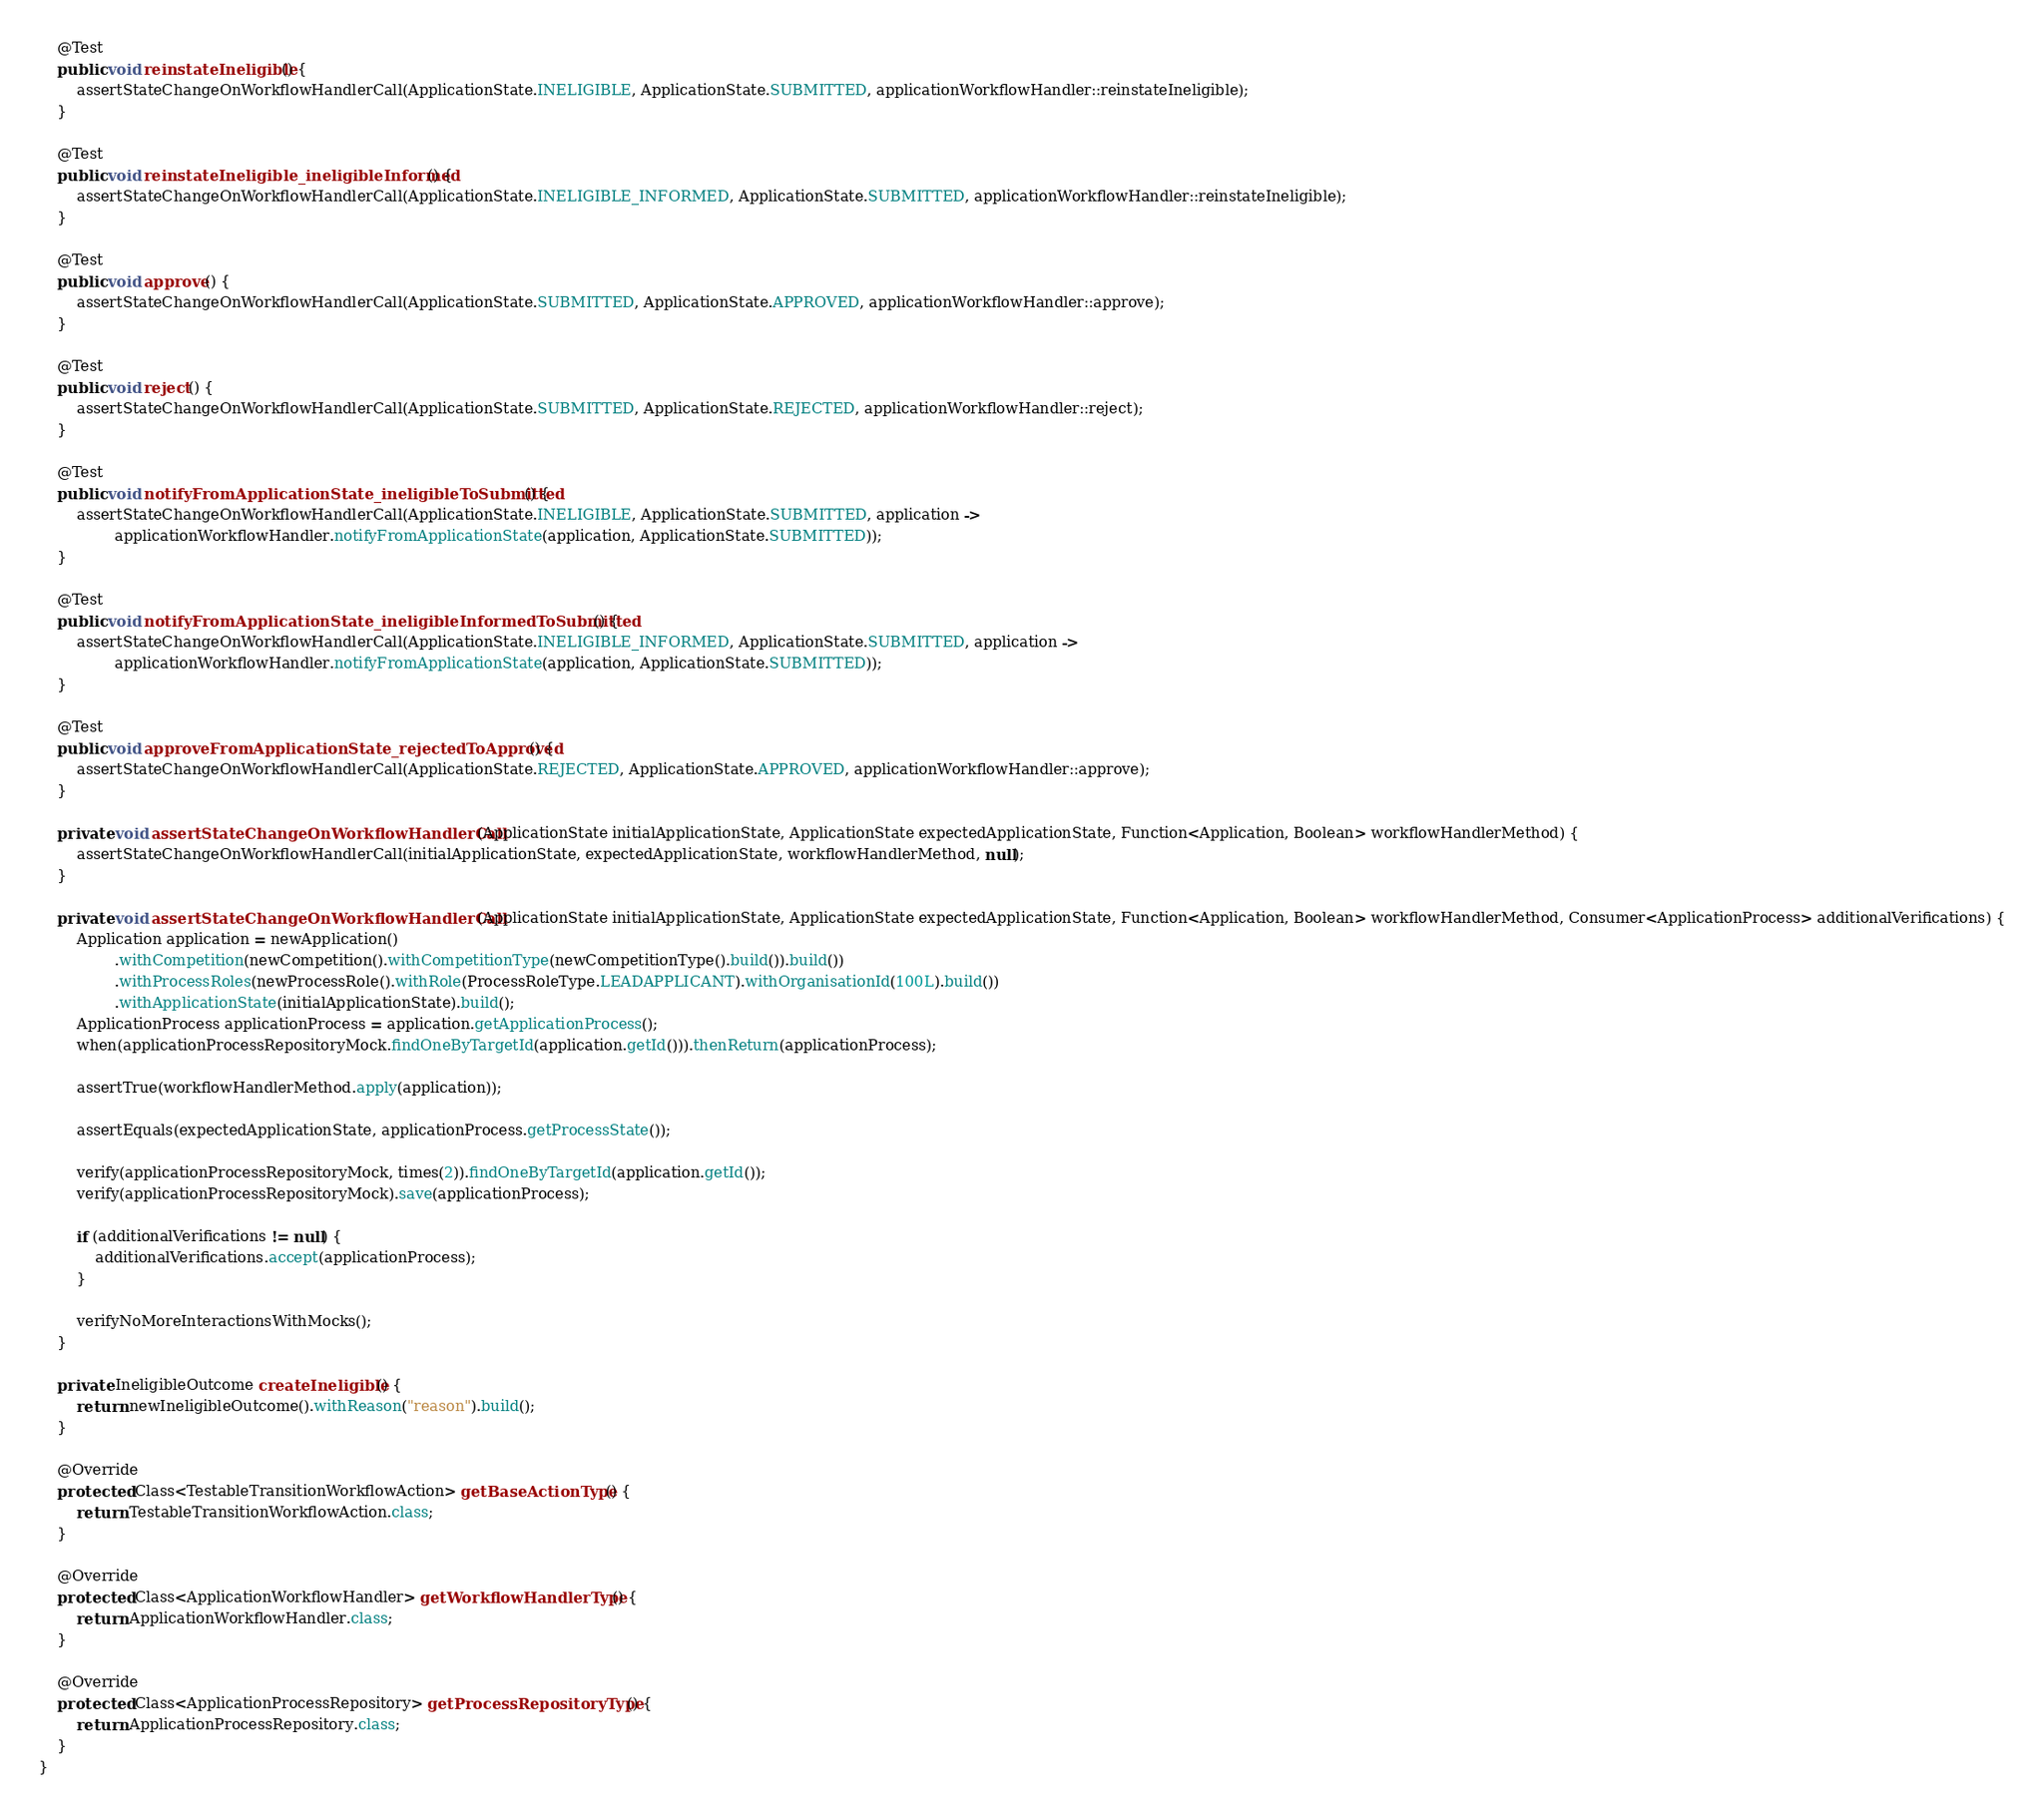Convert code to text. <code><loc_0><loc_0><loc_500><loc_500><_Java_>
    @Test
    public void reinstateIneligible() {
        assertStateChangeOnWorkflowHandlerCall(ApplicationState.INELIGIBLE, ApplicationState.SUBMITTED, applicationWorkflowHandler::reinstateIneligible);
    }

    @Test
    public void reinstateIneligible_ineligibleInformed() {
        assertStateChangeOnWorkflowHandlerCall(ApplicationState.INELIGIBLE_INFORMED, ApplicationState.SUBMITTED, applicationWorkflowHandler::reinstateIneligible);
    }

    @Test
    public void approve() {
        assertStateChangeOnWorkflowHandlerCall(ApplicationState.SUBMITTED, ApplicationState.APPROVED, applicationWorkflowHandler::approve);
    }

    @Test
    public void reject() {
        assertStateChangeOnWorkflowHandlerCall(ApplicationState.SUBMITTED, ApplicationState.REJECTED, applicationWorkflowHandler::reject);
    }

    @Test
    public void notifyFromApplicationState_ineligibleToSubmitted() {
        assertStateChangeOnWorkflowHandlerCall(ApplicationState.INELIGIBLE, ApplicationState.SUBMITTED, application ->
                applicationWorkflowHandler.notifyFromApplicationState(application, ApplicationState.SUBMITTED));
    }

    @Test
    public void notifyFromApplicationState_ineligibleInformedToSubmitted() {
        assertStateChangeOnWorkflowHandlerCall(ApplicationState.INELIGIBLE_INFORMED, ApplicationState.SUBMITTED, application ->
                applicationWorkflowHandler.notifyFromApplicationState(application, ApplicationState.SUBMITTED));
    }

    @Test
    public void approveFromApplicationState_rejectedToApproved() {
        assertStateChangeOnWorkflowHandlerCall(ApplicationState.REJECTED, ApplicationState.APPROVED, applicationWorkflowHandler::approve);
    }

    private void assertStateChangeOnWorkflowHandlerCall(ApplicationState initialApplicationState, ApplicationState expectedApplicationState, Function<Application, Boolean> workflowHandlerMethod) {
        assertStateChangeOnWorkflowHandlerCall(initialApplicationState, expectedApplicationState, workflowHandlerMethod, null);
    }

    private void assertStateChangeOnWorkflowHandlerCall(ApplicationState initialApplicationState, ApplicationState expectedApplicationState, Function<Application, Boolean> workflowHandlerMethod, Consumer<ApplicationProcess> additionalVerifications) {
        Application application = newApplication()
                .withCompetition(newCompetition().withCompetitionType(newCompetitionType().build()).build())
                .withProcessRoles(newProcessRole().withRole(ProcessRoleType.LEADAPPLICANT).withOrganisationId(100L).build())
                .withApplicationState(initialApplicationState).build();
        ApplicationProcess applicationProcess = application.getApplicationProcess();
        when(applicationProcessRepositoryMock.findOneByTargetId(application.getId())).thenReturn(applicationProcess);

        assertTrue(workflowHandlerMethod.apply(application));

        assertEquals(expectedApplicationState, applicationProcess.getProcessState());

        verify(applicationProcessRepositoryMock, times(2)).findOneByTargetId(application.getId());
        verify(applicationProcessRepositoryMock).save(applicationProcess);

        if (additionalVerifications != null) {
            additionalVerifications.accept(applicationProcess);
        }

        verifyNoMoreInteractionsWithMocks();
    }

    private IneligibleOutcome createIneligible() {
        return newIneligibleOutcome().withReason("reason").build();
    }

    @Override
    protected Class<TestableTransitionWorkflowAction> getBaseActionType() {
        return TestableTransitionWorkflowAction.class;
    }

    @Override
    protected Class<ApplicationWorkflowHandler> getWorkflowHandlerType() {
        return ApplicationWorkflowHandler.class;
    }

    @Override
    protected Class<ApplicationProcessRepository> getProcessRepositoryType() {
        return ApplicationProcessRepository.class;
    }
}</code> 